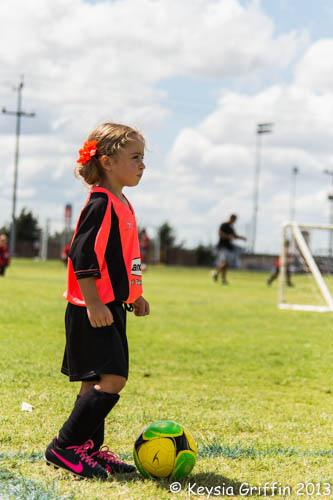What kind of poles stand erect in the background? electric 